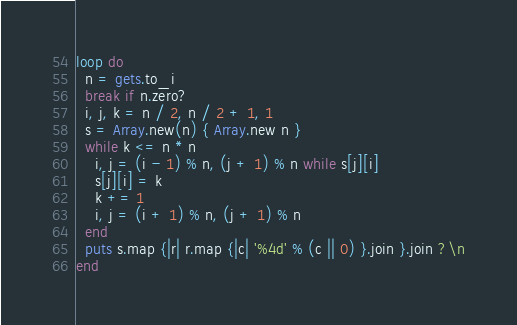Convert code to text. <code><loc_0><loc_0><loc_500><loc_500><_Ruby_>loop do
  n = gets.to_i
  break if n.zero?
  i, j, k = n / 2, n / 2 + 1, 1
  s = Array.new(n) { Array.new n }
  while k <= n * n
    i, j = (i - 1) % n, (j + 1) % n while s[j][i]
    s[j][i] = k
    k += 1
    i, j = (i + 1) % n, (j + 1) % n
  end
  puts s.map {|r| r.map {|c| '%4d' % (c || 0) }.join }.join ?\n
end</code> 